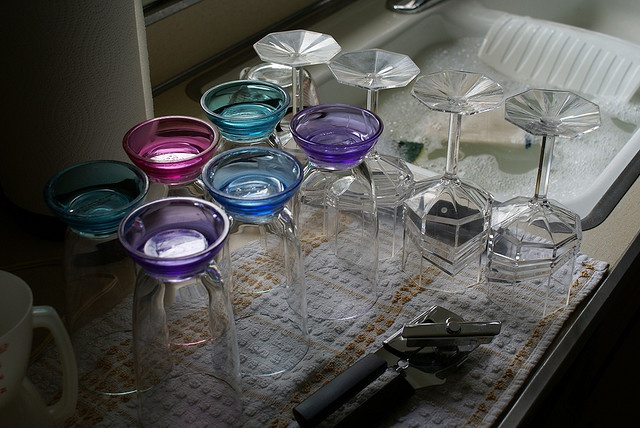Describe the objects in this image and their specific colors. I can see sink in black, darkgray, gray, and lightgray tones, cup in black, gray, and navy tones, cup in black, gray, and navy tones, cup in black, teal, darkblue, and gray tones, and cup in black, gray, and navy tones in this image. 